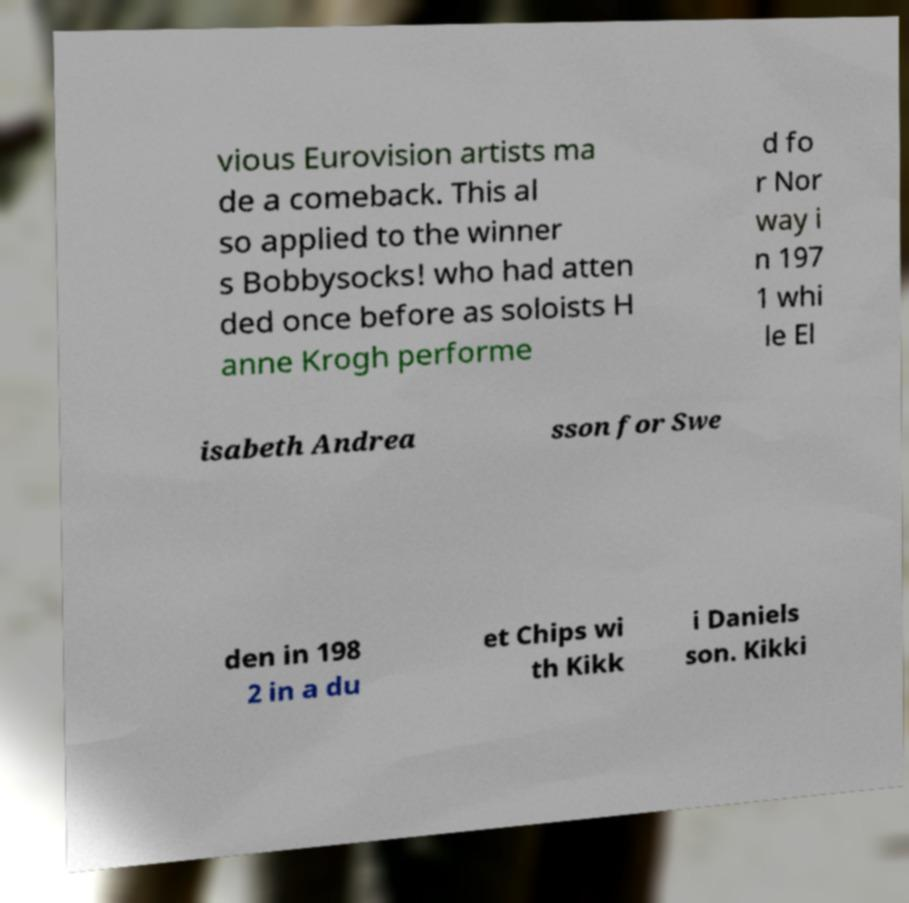Please identify and transcribe the text found in this image. vious Eurovision artists ma de a comeback. This al so applied to the winner s Bobbysocks! who had atten ded once before as soloists H anne Krogh performe d fo r Nor way i n 197 1 whi le El isabeth Andrea sson for Swe den in 198 2 in a du et Chips wi th Kikk i Daniels son. Kikki 